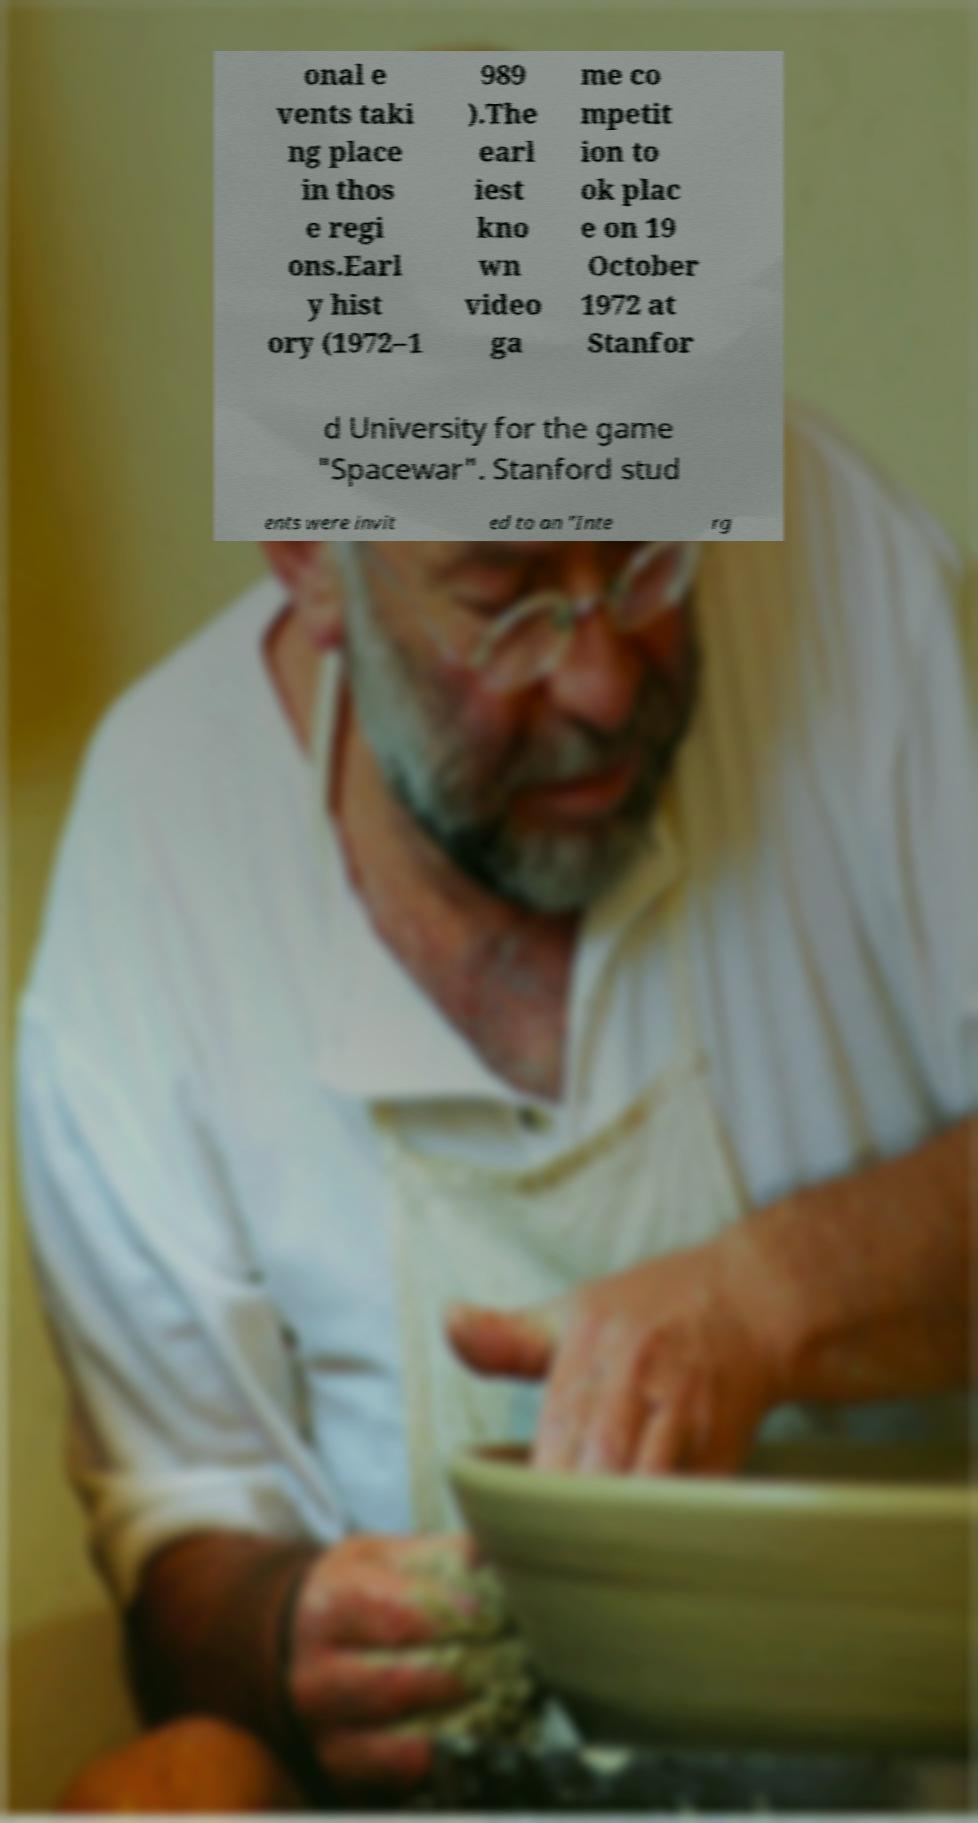There's text embedded in this image that I need extracted. Can you transcribe it verbatim? onal e vents taki ng place in thos e regi ons.Earl y hist ory (1972–1 989 ).The earl iest kno wn video ga me co mpetit ion to ok plac e on 19 October 1972 at Stanfor d University for the game "Spacewar". Stanford stud ents were invit ed to an "Inte rg 